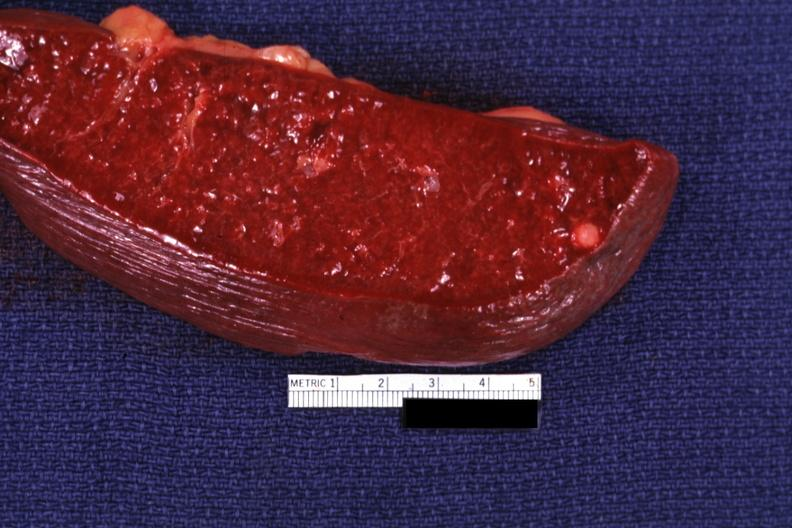what does this image show?
Answer the question using a single word or phrase. Cut surface with typical healed granuloma 